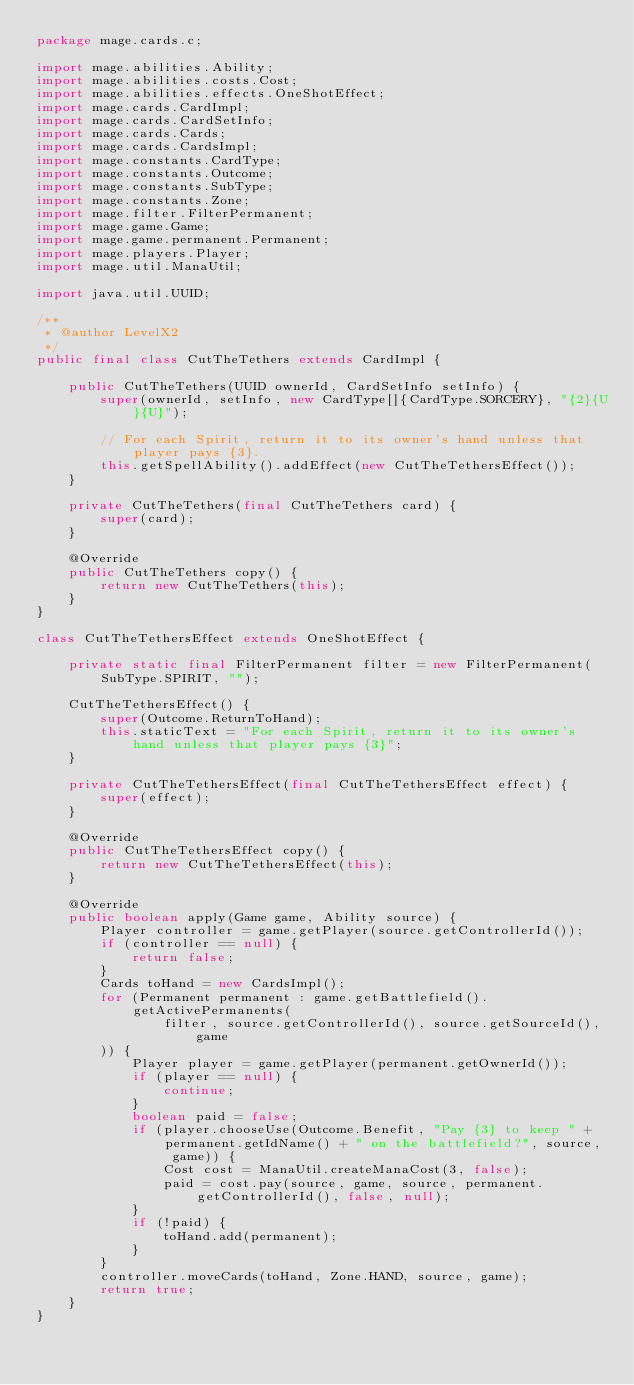<code> <loc_0><loc_0><loc_500><loc_500><_Java_>package mage.cards.c;

import mage.abilities.Ability;
import mage.abilities.costs.Cost;
import mage.abilities.effects.OneShotEffect;
import mage.cards.CardImpl;
import mage.cards.CardSetInfo;
import mage.cards.Cards;
import mage.cards.CardsImpl;
import mage.constants.CardType;
import mage.constants.Outcome;
import mage.constants.SubType;
import mage.constants.Zone;
import mage.filter.FilterPermanent;
import mage.game.Game;
import mage.game.permanent.Permanent;
import mage.players.Player;
import mage.util.ManaUtil;

import java.util.UUID;

/**
 * @author LevelX2
 */
public final class CutTheTethers extends CardImpl {

    public CutTheTethers(UUID ownerId, CardSetInfo setInfo) {
        super(ownerId, setInfo, new CardType[]{CardType.SORCERY}, "{2}{U}{U}");

        // For each Spirit, return it to its owner's hand unless that player pays {3}.
        this.getSpellAbility().addEffect(new CutTheTethersEffect());
    }

    private CutTheTethers(final CutTheTethers card) {
        super(card);
    }

    @Override
    public CutTheTethers copy() {
        return new CutTheTethers(this);
    }
}

class CutTheTethersEffect extends OneShotEffect {

    private static final FilterPermanent filter = new FilterPermanent(SubType.SPIRIT, "");

    CutTheTethersEffect() {
        super(Outcome.ReturnToHand);
        this.staticText = "For each Spirit, return it to its owner's hand unless that player pays {3}";
    }

    private CutTheTethersEffect(final CutTheTethersEffect effect) {
        super(effect);
    }

    @Override
    public CutTheTethersEffect copy() {
        return new CutTheTethersEffect(this);
    }

    @Override
    public boolean apply(Game game, Ability source) {
        Player controller = game.getPlayer(source.getControllerId());
        if (controller == null) {
            return false;
        }
        Cards toHand = new CardsImpl();
        for (Permanent permanent : game.getBattlefield().getActivePermanents(
                filter, source.getControllerId(), source.getSourceId(), game
        )) {
            Player player = game.getPlayer(permanent.getOwnerId());
            if (player == null) {
                continue;
            }
            boolean paid = false;
            if (player.chooseUse(Outcome.Benefit, "Pay {3} to keep " + permanent.getIdName() + " on the battlefield?", source, game)) {
                Cost cost = ManaUtil.createManaCost(3, false);
                paid = cost.pay(source, game, source, permanent.getControllerId(), false, null);
            }
            if (!paid) {
                toHand.add(permanent);
            }
        }
        controller.moveCards(toHand, Zone.HAND, source, game);
        return true;
    }
}
</code> 